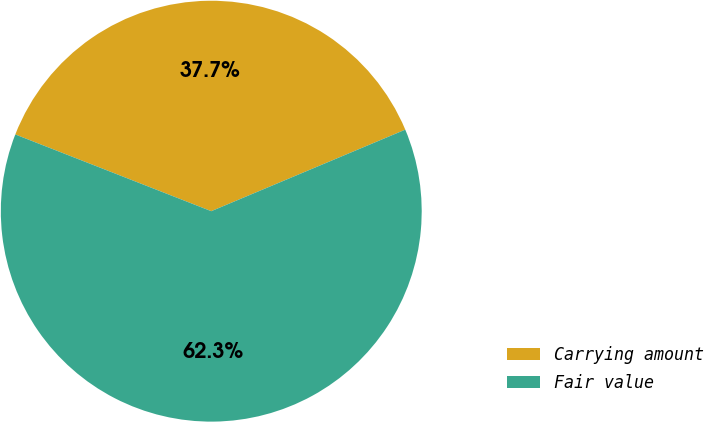Convert chart. <chart><loc_0><loc_0><loc_500><loc_500><pie_chart><fcel>Carrying amount<fcel>Fair value<nl><fcel>37.73%<fcel>62.27%<nl></chart> 